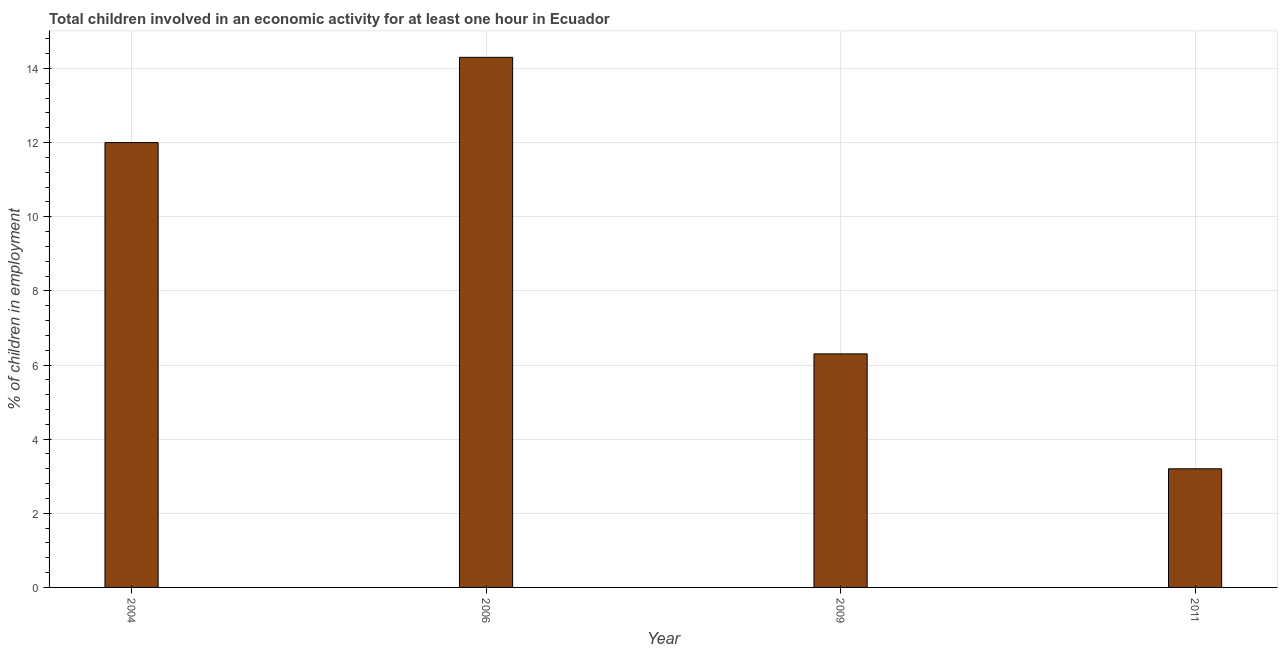Does the graph contain any zero values?
Ensure brevity in your answer.  No. What is the title of the graph?
Your answer should be very brief. Total children involved in an economic activity for at least one hour in Ecuador. What is the label or title of the X-axis?
Your answer should be very brief. Year. What is the label or title of the Y-axis?
Offer a terse response. % of children in employment. What is the percentage of children in employment in 2006?
Keep it short and to the point. 14.3. Across all years, what is the minimum percentage of children in employment?
Provide a succinct answer. 3.2. In which year was the percentage of children in employment minimum?
Make the answer very short. 2011. What is the sum of the percentage of children in employment?
Your response must be concise. 35.8. What is the average percentage of children in employment per year?
Offer a terse response. 8.95. What is the median percentage of children in employment?
Your answer should be very brief. 9.15. What is the ratio of the percentage of children in employment in 2009 to that in 2011?
Your answer should be compact. 1.97. Is the difference between the percentage of children in employment in 2004 and 2009 greater than the difference between any two years?
Give a very brief answer. No. What is the difference between the highest and the second highest percentage of children in employment?
Give a very brief answer. 2.3. In how many years, is the percentage of children in employment greater than the average percentage of children in employment taken over all years?
Your response must be concise. 2. Are all the bars in the graph horizontal?
Ensure brevity in your answer.  No. Are the values on the major ticks of Y-axis written in scientific E-notation?
Give a very brief answer. No. What is the % of children in employment in 2004?
Provide a short and direct response. 12. What is the % of children in employment in 2011?
Your answer should be compact. 3.2. What is the difference between the % of children in employment in 2004 and 2006?
Give a very brief answer. -2.3. What is the difference between the % of children in employment in 2004 and 2009?
Your answer should be very brief. 5.7. What is the difference between the % of children in employment in 2006 and 2009?
Offer a very short reply. 8. What is the difference between the % of children in employment in 2006 and 2011?
Make the answer very short. 11.1. What is the ratio of the % of children in employment in 2004 to that in 2006?
Offer a very short reply. 0.84. What is the ratio of the % of children in employment in 2004 to that in 2009?
Offer a very short reply. 1.91. What is the ratio of the % of children in employment in 2004 to that in 2011?
Provide a short and direct response. 3.75. What is the ratio of the % of children in employment in 2006 to that in 2009?
Provide a succinct answer. 2.27. What is the ratio of the % of children in employment in 2006 to that in 2011?
Your answer should be very brief. 4.47. What is the ratio of the % of children in employment in 2009 to that in 2011?
Make the answer very short. 1.97. 